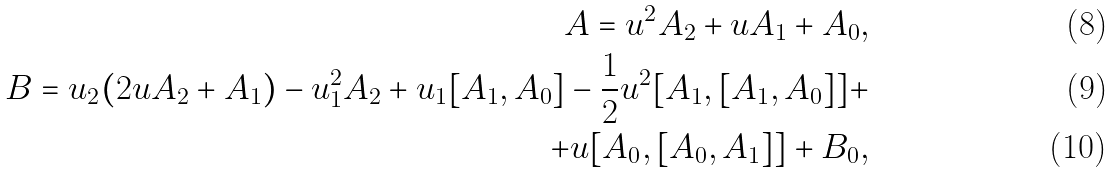Convert formula to latex. <formula><loc_0><loc_0><loc_500><loc_500>A = u ^ { 2 } A _ { 2 } + u A _ { 1 } + A _ { 0 } , \\ B = u _ { 2 } ( 2 u A _ { 2 } + A _ { 1 } ) - u _ { 1 } ^ { 2 } A _ { 2 } + u _ { 1 } [ A _ { 1 } , A _ { 0 } ] - \frac { 1 } { 2 } u ^ { 2 } [ A _ { 1 } , [ A _ { 1 } , A _ { 0 } ] ] + \\ + u [ A _ { 0 } , [ A _ { 0 } , A _ { 1 } ] ] + B _ { 0 } ,</formula> 